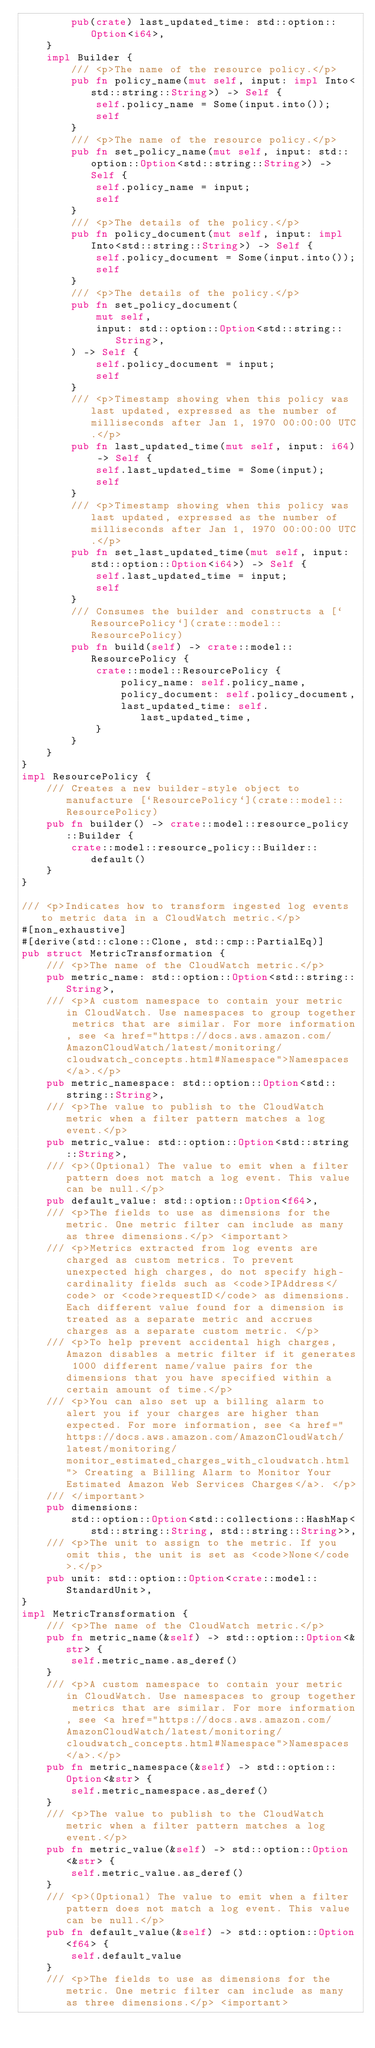Convert code to text. <code><loc_0><loc_0><loc_500><loc_500><_Rust_>        pub(crate) last_updated_time: std::option::Option<i64>,
    }
    impl Builder {
        /// <p>The name of the resource policy.</p>
        pub fn policy_name(mut self, input: impl Into<std::string::String>) -> Self {
            self.policy_name = Some(input.into());
            self
        }
        /// <p>The name of the resource policy.</p>
        pub fn set_policy_name(mut self, input: std::option::Option<std::string::String>) -> Self {
            self.policy_name = input;
            self
        }
        /// <p>The details of the policy.</p>
        pub fn policy_document(mut self, input: impl Into<std::string::String>) -> Self {
            self.policy_document = Some(input.into());
            self
        }
        /// <p>The details of the policy.</p>
        pub fn set_policy_document(
            mut self,
            input: std::option::Option<std::string::String>,
        ) -> Self {
            self.policy_document = input;
            self
        }
        /// <p>Timestamp showing when this policy was last updated, expressed as the number of milliseconds after Jan 1, 1970 00:00:00 UTC.</p>
        pub fn last_updated_time(mut self, input: i64) -> Self {
            self.last_updated_time = Some(input);
            self
        }
        /// <p>Timestamp showing when this policy was last updated, expressed as the number of milliseconds after Jan 1, 1970 00:00:00 UTC.</p>
        pub fn set_last_updated_time(mut self, input: std::option::Option<i64>) -> Self {
            self.last_updated_time = input;
            self
        }
        /// Consumes the builder and constructs a [`ResourcePolicy`](crate::model::ResourcePolicy)
        pub fn build(self) -> crate::model::ResourcePolicy {
            crate::model::ResourcePolicy {
                policy_name: self.policy_name,
                policy_document: self.policy_document,
                last_updated_time: self.last_updated_time,
            }
        }
    }
}
impl ResourcePolicy {
    /// Creates a new builder-style object to manufacture [`ResourcePolicy`](crate::model::ResourcePolicy)
    pub fn builder() -> crate::model::resource_policy::Builder {
        crate::model::resource_policy::Builder::default()
    }
}

/// <p>Indicates how to transform ingested log events to metric data in a CloudWatch metric.</p>
#[non_exhaustive]
#[derive(std::clone::Clone, std::cmp::PartialEq)]
pub struct MetricTransformation {
    /// <p>The name of the CloudWatch metric.</p>
    pub metric_name: std::option::Option<std::string::String>,
    /// <p>A custom namespace to contain your metric in CloudWatch. Use namespaces to group together metrics that are similar. For more information, see <a href="https://docs.aws.amazon.com/AmazonCloudWatch/latest/monitoring/cloudwatch_concepts.html#Namespace">Namespaces</a>.</p>
    pub metric_namespace: std::option::Option<std::string::String>,
    /// <p>The value to publish to the CloudWatch metric when a filter pattern matches a log event.</p>
    pub metric_value: std::option::Option<std::string::String>,
    /// <p>(Optional) The value to emit when a filter pattern does not match a log event. This value can be null.</p>
    pub default_value: std::option::Option<f64>,
    /// <p>The fields to use as dimensions for the metric. One metric filter can include as many as three dimensions.</p> <important>
    /// <p>Metrics extracted from log events are charged as custom metrics. To prevent unexpected high charges, do not specify high-cardinality fields such as <code>IPAddress</code> or <code>requestID</code> as dimensions. Each different value found for a dimension is treated as a separate metric and accrues charges as a separate custom metric. </p>
    /// <p>To help prevent accidental high charges, Amazon disables a metric filter if it generates 1000 different name/value pairs for the dimensions that you have specified within a certain amount of time.</p>
    /// <p>You can also set up a billing alarm to alert you if your charges are higher than expected. For more information, see <a href="https://docs.aws.amazon.com/AmazonCloudWatch/latest/monitoring/monitor_estimated_charges_with_cloudwatch.html"> Creating a Billing Alarm to Monitor Your Estimated Amazon Web Services Charges</a>. </p>
    /// </important>
    pub dimensions:
        std::option::Option<std::collections::HashMap<std::string::String, std::string::String>>,
    /// <p>The unit to assign to the metric. If you omit this, the unit is set as <code>None</code>.</p>
    pub unit: std::option::Option<crate::model::StandardUnit>,
}
impl MetricTransformation {
    /// <p>The name of the CloudWatch metric.</p>
    pub fn metric_name(&self) -> std::option::Option<&str> {
        self.metric_name.as_deref()
    }
    /// <p>A custom namespace to contain your metric in CloudWatch. Use namespaces to group together metrics that are similar. For more information, see <a href="https://docs.aws.amazon.com/AmazonCloudWatch/latest/monitoring/cloudwatch_concepts.html#Namespace">Namespaces</a>.</p>
    pub fn metric_namespace(&self) -> std::option::Option<&str> {
        self.metric_namespace.as_deref()
    }
    /// <p>The value to publish to the CloudWatch metric when a filter pattern matches a log event.</p>
    pub fn metric_value(&self) -> std::option::Option<&str> {
        self.metric_value.as_deref()
    }
    /// <p>(Optional) The value to emit when a filter pattern does not match a log event. This value can be null.</p>
    pub fn default_value(&self) -> std::option::Option<f64> {
        self.default_value
    }
    /// <p>The fields to use as dimensions for the metric. One metric filter can include as many as three dimensions.</p> <important></code> 